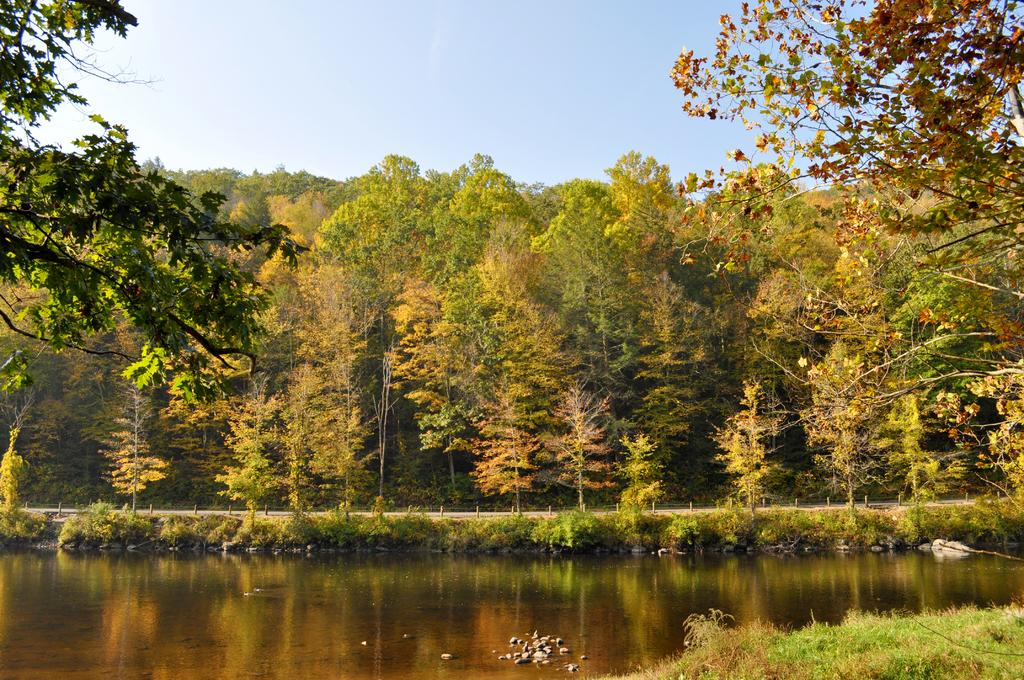What type of vegetation can be seen in the image? There are trees, plants, and grass in the image. What body of water is present in the image? There is a lake in the image. What type of terrain is visible in the image? There are rocks in the image. What man-made structure can be seen in the image? There is a road and a fence in the image. What is visible at the top of the image? The sky is visible at the top of the image. How many cars are parked next to the crate in the image? There are no cars or crates present in the image. What type of snail can be seen crawling on the fence in the image? There are no snails visible in the image. 